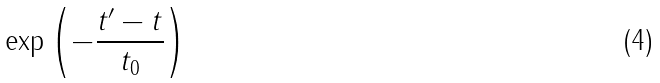Convert formula to latex. <formula><loc_0><loc_0><loc_500><loc_500>\exp \left ( - { \frac { t ^ { \prime } - t } { t _ { 0 } } } \right )</formula> 